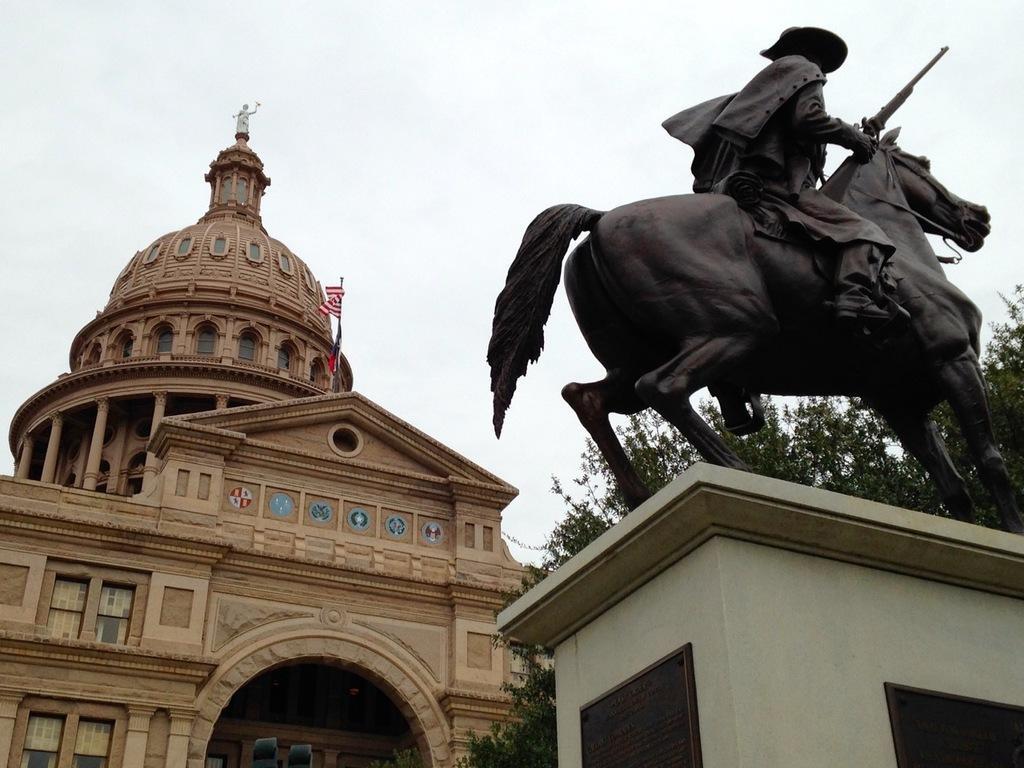Please provide a concise description of this image. In the foreground of the picture there is a statue of a person on the horse. In the center of the picture there is tree. On the left there is a building, on the building there are flags and statue. In the background it is sky, sky is cloudy. 